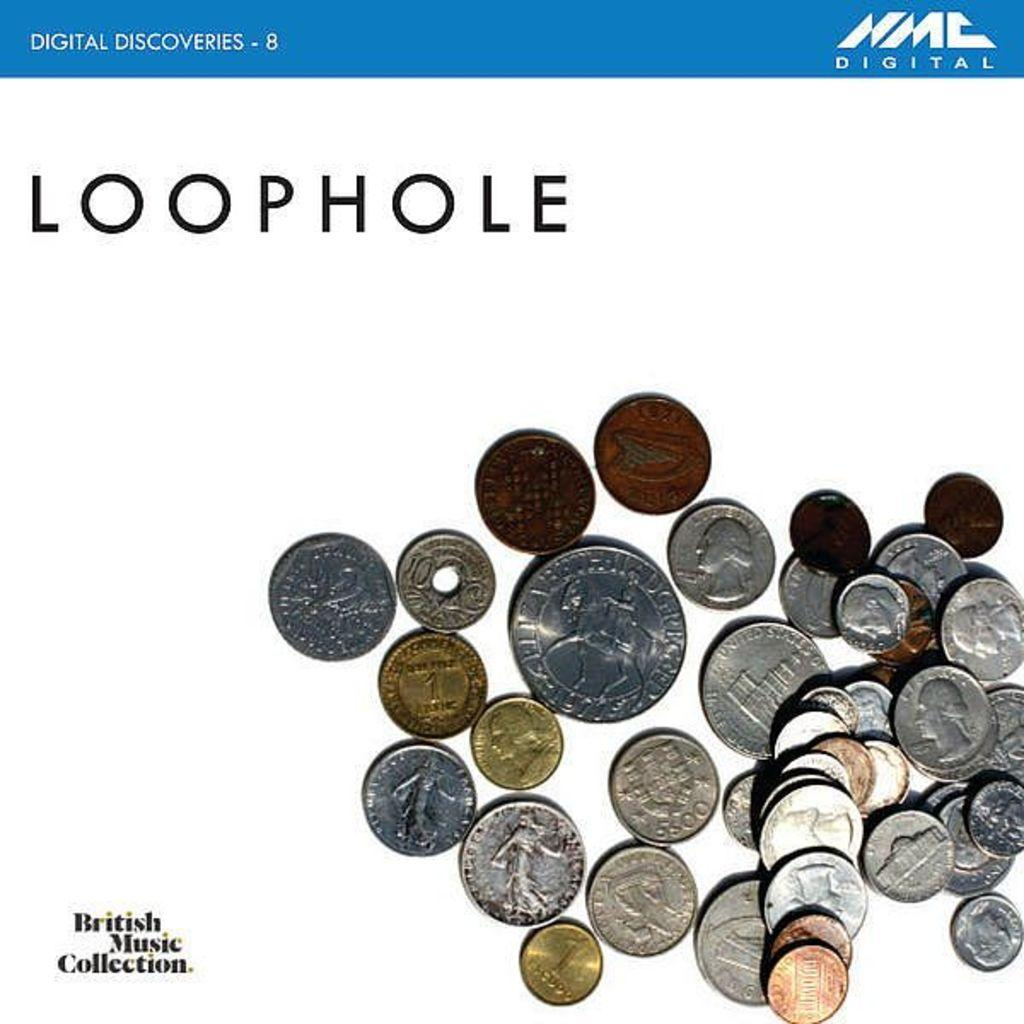<image>
Give a short and clear explanation of the subsequent image. coins on a white background from the British Music Collection 